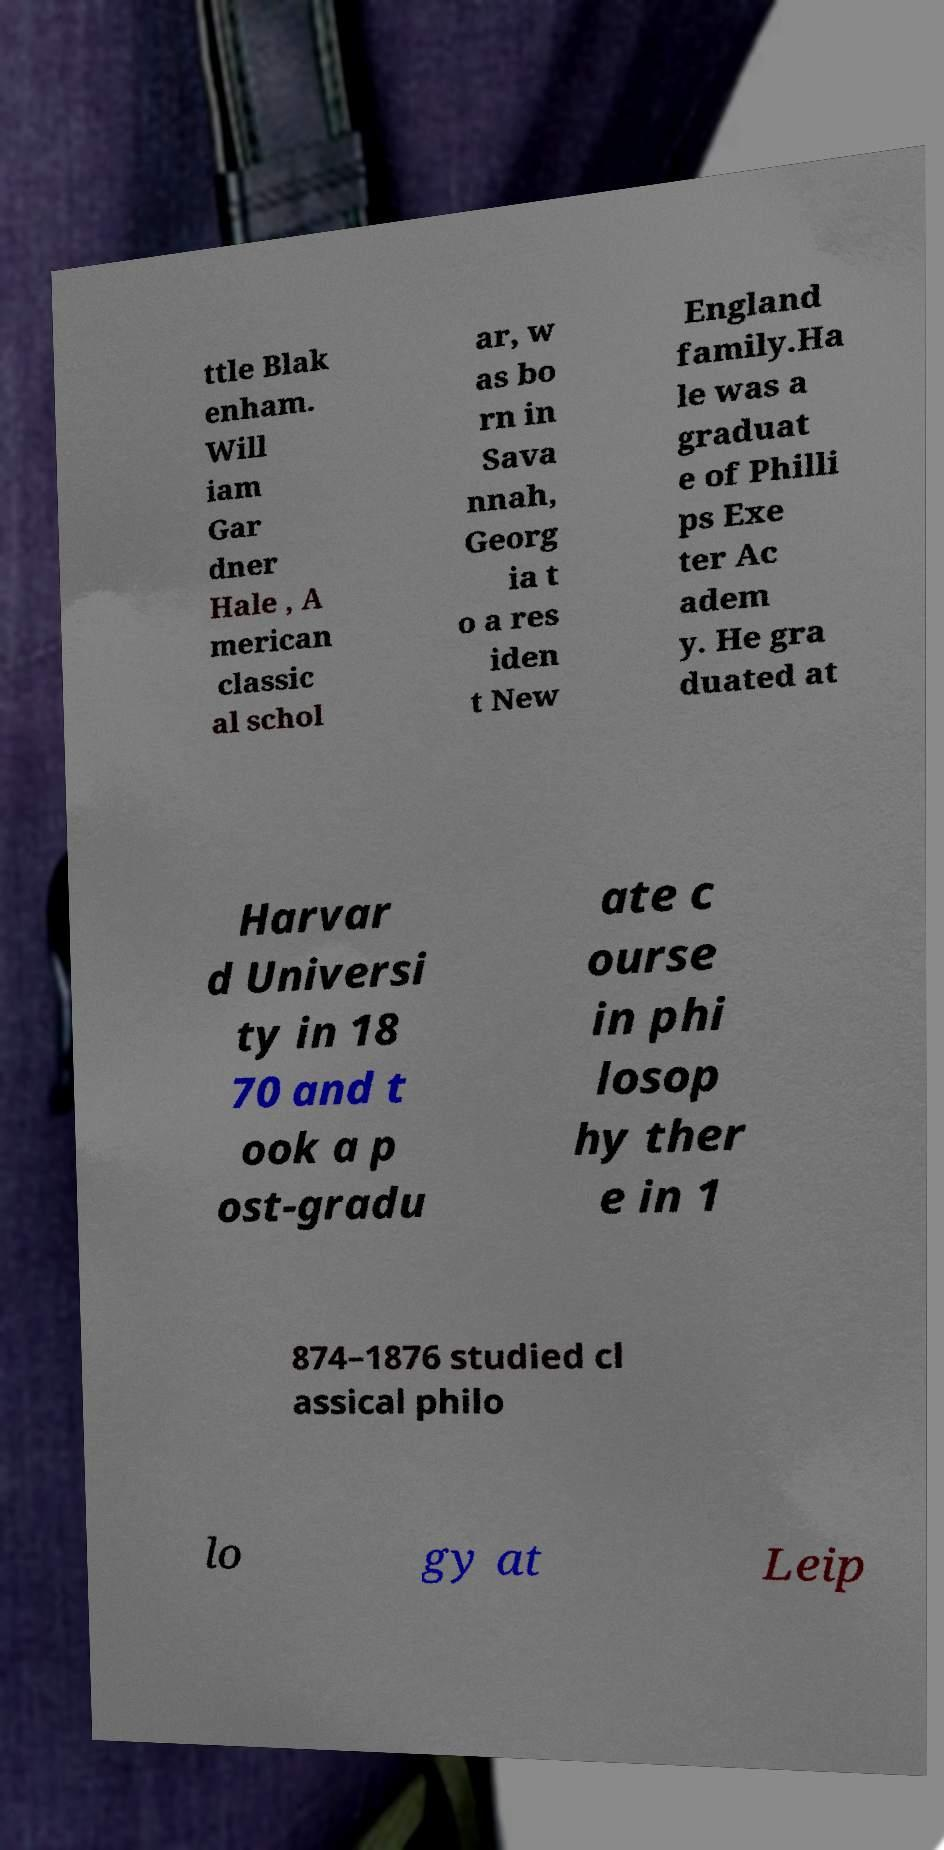What messages or text are displayed in this image? I need them in a readable, typed format. ttle Blak enham. Will iam Gar dner Hale , A merican classic al schol ar, w as bo rn in Sava nnah, Georg ia t o a res iden t New England family.Ha le was a graduat e of Philli ps Exe ter Ac adem y. He gra duated at Harvar d Universi ty in 18 70 and t ook a p ost-gradu ate c ourse in phi losop hy ther e in 1 874–1876 studied cl assical philo lo gy at Leip 